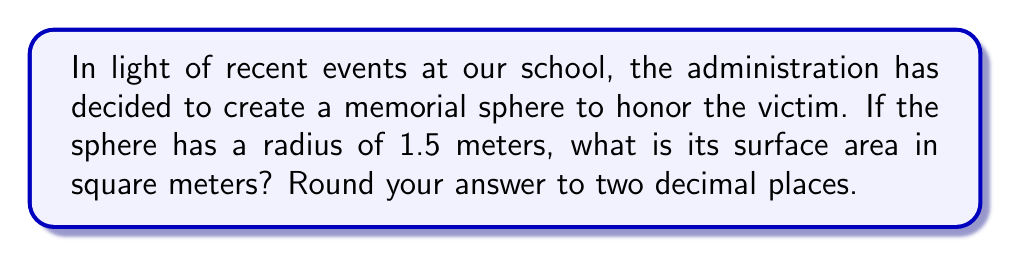Help me with this question. To solve this problem, we'll use the formula for the surface area of a sphere:

$$ A = 4\pi r^2 $$

Where:
$A$ is the surface area
$r$ is the radius of the sphere

Given:
$r = 1.5$ meters

Let's substitute this into our formula:

$$ A = 4\pi (1.5)^2 $$

Now, let's calculate step by step:

1) First, calculate $1.5^2$:
   $1.5^2 = 2.25$

2) Multiply by $4\pi$:
   $4\pi \times 2.25 = 9\pi$

3) Calculate the value of $9\pi$:
   $9 \times 3.14159... \approx 28.2743...$

4) Round to two decimal places:
   $28.27$ square meters
Answer: $28.27$ square meters 